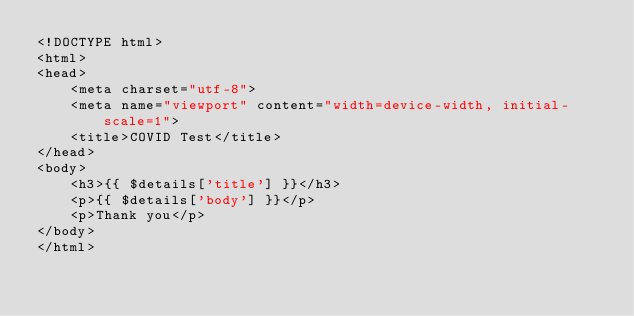<code> <loc_0><loc_0><loc_500><loc_500><_PHP_><!DOCTYPE html>
<html>
<head>
	<meta charset="utf-8">
	<meta name="viewport" content="width=device-width, initial-scale=1">
	<title>COVID Test</title>
</head>
<body>
	<h3>{{ $details['title'] }}</h3>
	<p>{{ $details['body'] }}</p>
	<p>Thank you</p>
</body>
</html></code> 